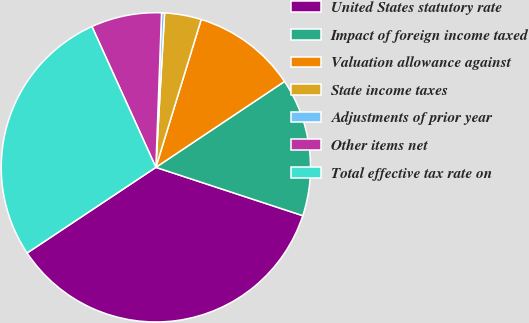Convert chart. <chart><loc_0><loc_0><loc_500><loc_500><pie_chart><fcel>United States statutory rate<fcel>Impact of foreign income taxed<fcel>Valuation allowance against<fcel>State income taxes<fcel>Adjustments of prior year<fcel>Other items net<fcel>Total effective tax rate on<nl><fcel>35.61%<fcel>14.43%<fcel>10.9%<fcel>3.84%<fcel>0.31%<fcel>7.37%<fcel>27.57%<nl></chart> 